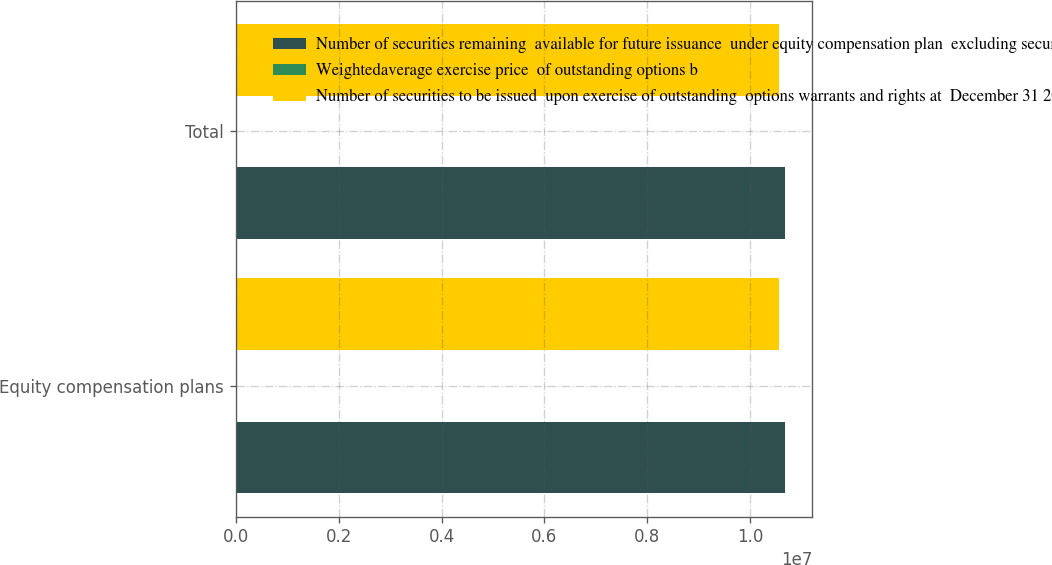Convert chart to OTSL. <chart><loc_0><loc_0><loc_500><loc_500><stacked_bar_chart><ecel><fcel>Equity compensation plans<fcel>Total<nl><fcel>Number of securities remaining  available for future issuance  under equity compensation plan  excluding securities reflected in  column a at December 31  2007 c<fcel>1.06762e+07<fcel>1.06762e+07<nl><fcel>Weightedaverage exercise price  of outstanding options b<fcel>36.86<fcel>36.86<nl><fcel>Number of securities to be issued  upon exercise of outstanding  options warrants and rights at  December 31 2007 a<fcel>1.05603e+07<fcel>1.05603e+07<nl></chart> 